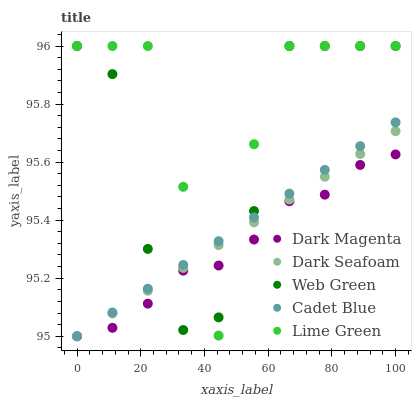Does Dark Magenta have the minimum area under the curve?
Answer yes or no. Yes. Does Lime Green have the maximum area under the curve?
Answer yes or no. Yes. Does Cadet Blue have the minimum area under the curve?
Answer yes or no. No. Does Cadet Blue have the maximum area under the curve?
Answer yes or no. No. Is Dark Seafoam the smoothest?
Answer yes or no. Yes. Is Lime Green the roughest?
Answer yes or no. Yes. Is Cadet Blue the smoothest?
Answer yes or no. No. Is Cadet Blue the roughest?
Answer yes or no. No. Does Dark Seafoam have the lowest value?
Answer yes or no. Yes. Does Lime Green have the lowest value?
Answer yes or no. No. Does Web Green have the highest value?
Answer yes or no. Yes. Does Cadet Blue have the highest value?
Answer yes or no. No. Does Dark Magenta intersect Cadet Blue?
Answer yes or no. Yes. Is Dark Magenta less than Cadet Blue?
Answer yes or no. No. Is Dark Magenta greater than Cadet Blue?
Answer yes or no. No. 